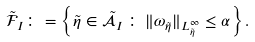<formula> <loc_0><loc_0><loc_500><loc_500>\mathcal { \tilde { F } } _ { I } \colon = \left \{ \tilde { \eta } \in \mathcal { \tilde { A } } _ { I } \, \colon \, \| \omega _ { \tilde { \eta } } \| _ { L ^ { \infty } _ { \tilde { \eta } } } \leq \alpha \right \} .</formula> 